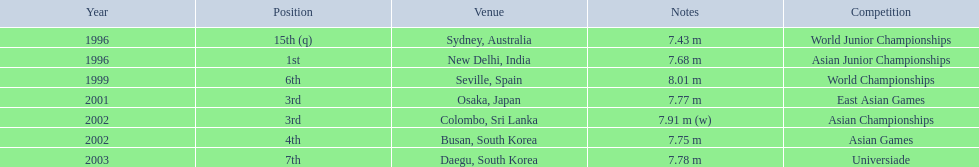Parse the full table in json format. {'header': ['Year', 'Position', 'Venue', 'Notes', 'Competition'], 'rows': [['1996', '15th (q)', 'Sydney, Australia', '7.43 m', 'World Junior Championships'], ['1996', '1st', 'New Delhi, India', '7.68 m', 'Asian Junior Championships'], ['1999', '6th', 'Seville, Spain', '8.01 m', 'World Championships'], ['2001', '3rd', 'Osaka, Japan', '7.77 m', 'East Asian Games'], ['2002', '3rd', 'Colombo, Sri Lanka', '7.91 m (w)', 'Asian Championships'], ['2002', '4th', 'Busan, South Korea', '7.75 m', 'Asian Games'], ['2003', '7th', 'Daegu, South Korea', '7.78 m', 'Universiade']]} What rankings has this competitor placed through the competitions? 15th (q), 1st, 6th, 3rd, 3rd, 4th, 7th. In which competition did the competitor place 1st? Asian Junior Championships. 